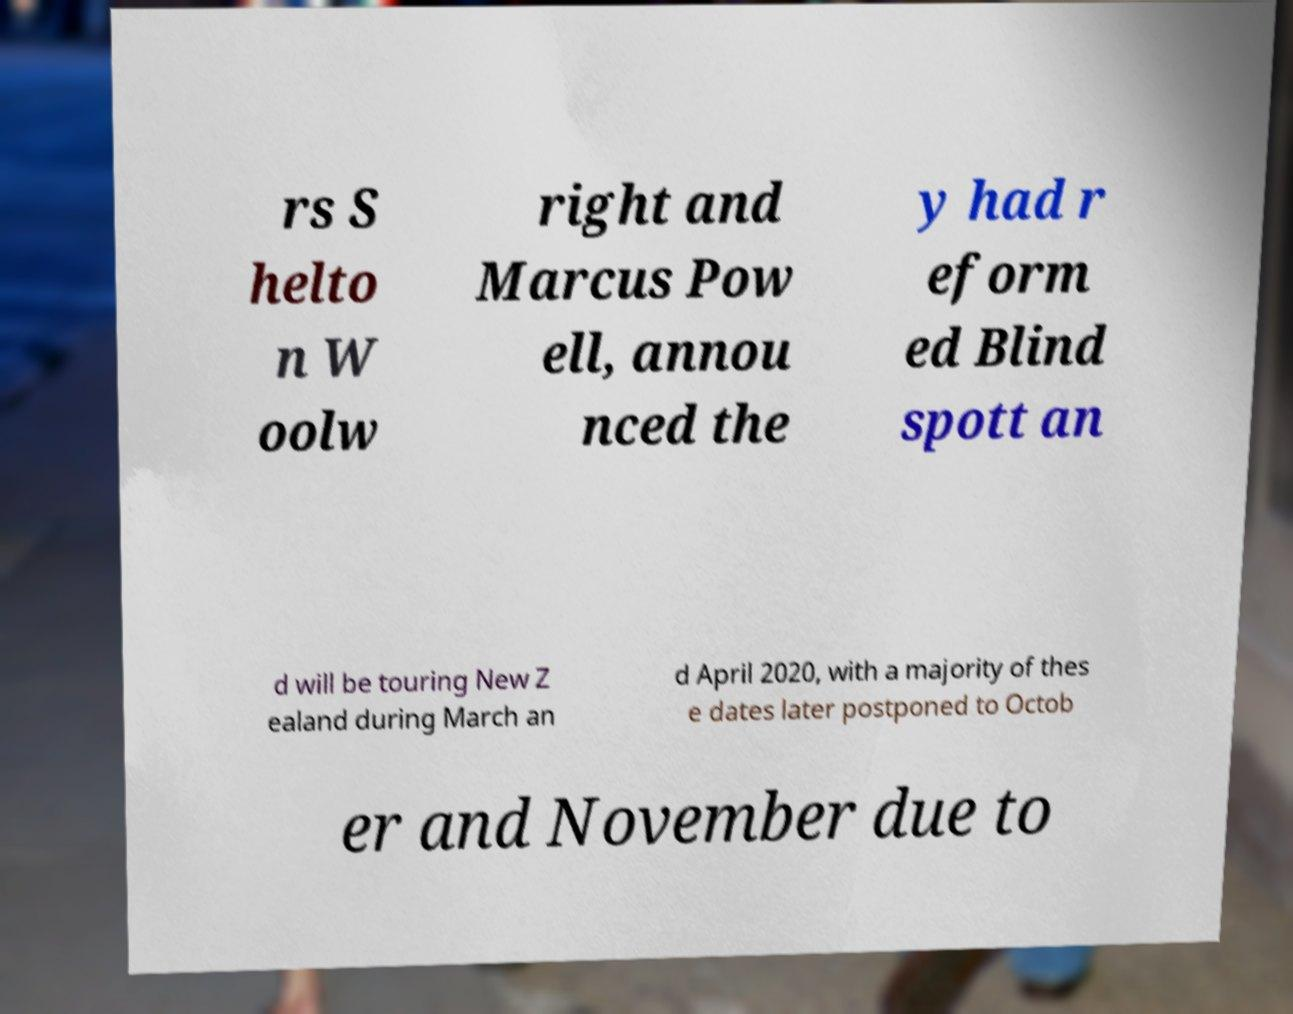Could you extract and type out the text from this image? rs S helto n W oolw right and Marcus Pow ell, annou nced the y had r eform ed Blind spott an d will be touring New Z ealand during March an d April 2020, with a majority of thes e dates later postponed to Octob er and November due to 